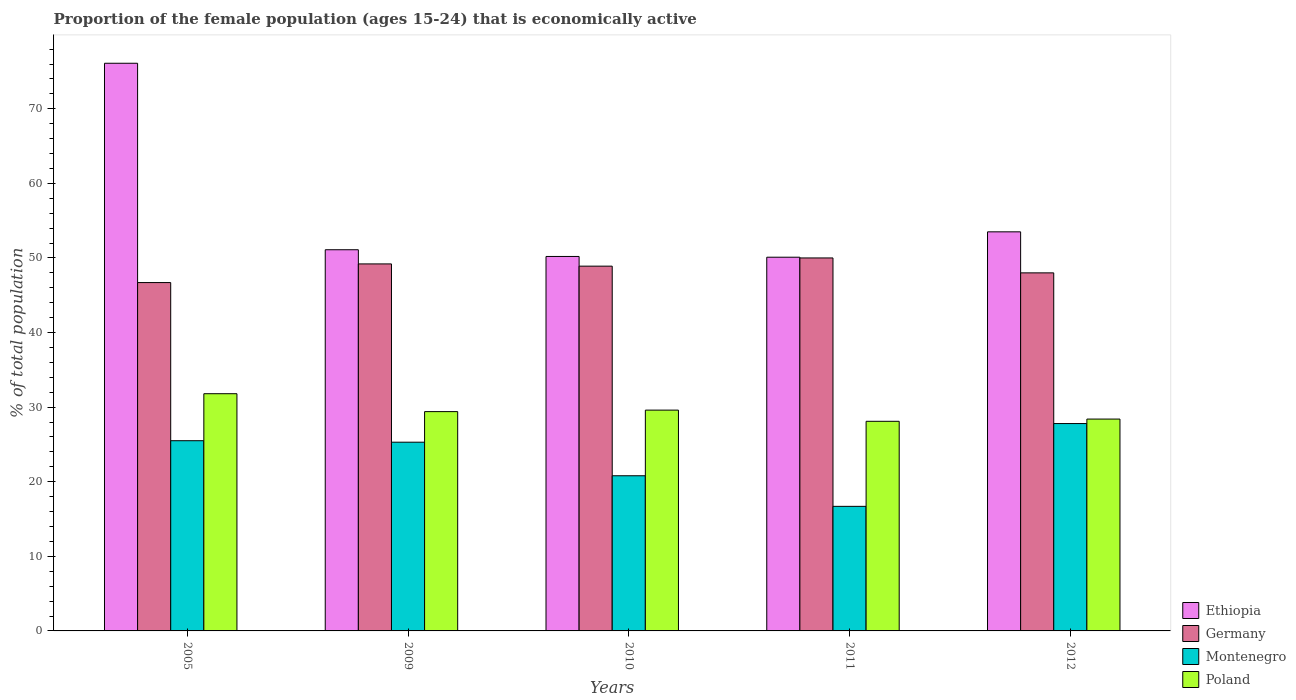How many different coloured bars are there?
Your response must be concise. 4. Are the number of bars per tick equal to the number of legend labels?
Offer a very short reply. Yes. Are the number of bars on each tick of the X-axis equal?
Give a very brief answer. Yes. How many bars are there on the 1st tick from the right?
Your answer should be compact. 4. In how many cases, is the number of bars for a given year not equal to the number of legend labels?
Your answer should be compact. 0. What is the proportion of the female population that is economically active in Germany in 2010?
Provide a succinct answer. 48.9. Across all years, what is the minimum proportion of the female population that is economically active in Montenegro?
Provide a succinct answer. 16.7. In which year was the proportion of the female population that is economically active in Germany maximum?
Offer a very short reply. 2011. What is the total proportion of the female population that is economically active in Montenegro in the graph?
Provide a short and direct response. 116.1. What is the difference between the proportion of the female population that is economically active in Germany in 2010 and that in 2011?
Offer a terse response. -1.1. What is the difference between the proportion of the female population that is economically active in Poland in 2011 and the proportion of the female population that is economically active in Ethiopia in 2009?
Ensure brevity in your answer.  -23. What is the average proportion of the female population that is economically active in Germany per year?
Offer a very short reply. 48.56. In the year 2005, what is the difference between the proportion of the female population that is economically active in Montenegro and proportion of the female population that is economically active in Poland?
Offer a very short reply. -6.3. What is the ratio of the proportion of the female population that is economically active in Poland in 2005 to that in 2011?
Give a very brief answer. 1.13. Is the proportion of the female population that is economically active in Ethiopia in 2010 less than that in 2011?
Your answer should be compact. No. What is the difference between the highest and the second highest proportion of the female population that is economically active in Ethiopia?
Keep it short and to the point. 22.6. What is the difference between the highest and the lowest proportion of the female population that is economically active in Montenegro?
Provide a succinct answer. 11.1. In how many years, is the proportion of the female population that is economically active in Ethiopia greater than the average proportion of the female population that is economically active in Ethiopia taken over all years?
Provide a short and direct response. 1. Is the sum of the proportion of the female population that is economically active in Montenegro in 2005 and 2012 greater than the maximum proportion of the female population that is economically active in Ethiopia across all years?
Your response must be concise. No. What does the 2nd bar from the left in 2012 represents?
Your answer should be compact. Germany. What does the 3rd bar from the right in 2011 represents?
Keep it short and to the point. Germany. How many years are there in the graph?
Your response must be concise. 5. Does the graph contain any zero values?
Make the answer very short. No. Does the graph contain grids?
Keep it short and to the point. No. Where does the legend appear in the graph?
Ensure brevity in your answer.  Bottom right. What is the title of the graph?
Make the answer very short. Proportion of the female population (ages 15-24) that is economically active. Does "St. Martin (French part)" appear as one of the legend labels in the graph?
Offer a terse response. No. What is the label or title of the Y-axis?
Give a very brief answer. % of total population. What is the % of total population in Ethiopia in 2005?
Offer a very short reply. 76.1. What is the % of total population of Germany in 2005?
Give a very brief answer. 46.7. What is the % of total population in Montenegro in 2005?
Offer a very short reply. 25.5. What is the % of total population of Poland in 2005?
Provide a succinct answer. 31.8. What is the % of total population in Ethiopia in 2009?
Your answer should be very brief. 51.1. What is the % of total population in Germany in 2009?
Offer a terse response. 49.2. What is the % of total population of Montenegro in 2009?
Give a very brief answer. 25.3. What is the % of total population of Poland in 2009?
Keep it short and to the point. 29.4. What is the % of total population in Ethiopia in 2010?
Offer a terse response. 50.2. What is the % of total population in Germany in 2010?
Keep it short and to the point. 48.9. What is the % of total population in Montenegro in 2010?
Give a very brief answer. 20.8. What is the % of total population in Poland in 2010?
Your answer should be compact. 29.6. What is the % of total population in Ethiopia in 2011?
Give a very brief answer. 50.1. What is the % of total population of Germany in 2011?
Ensure brevity in your answer.  50. What is the % of total population in Montenegro in 2011?
Provide a succinct answer. 16.7. What is the % of total population in Poland in 2011?
Give a very brief answer. 28.1. What is the % of total population in Ethiopia in 2012?
Make the answer very short. 53.5. What is the % of total population in Germany in 2012?
Make the answer very short. 48. What is the % of total population in Montenegro in 2012?
Offer a very short reply. 27.8. What is the % of total population of Poland in 2012?
Keep it short and to the point. 28.4. Across all years, what is the maximum % of total population of Ethiopia?
Provide a short and direct response. 76.1. Across all years, what is the maximum % of total population in Montenegro?
Offer a very short reply. 27.8. Across all years, what is the maximum % of total population of Poland?
Ensure brevity in your answer.  31.8. Across all years, what is the minimum % of total population in Ethiopia?
Ensure brevity in your answer.  50.1. Across all years, what is the minimum % of total population in Germany?
Ensure brevity in your answer.  46.7. Across all years, what is the minimum % of total population of Montenegro?
Provide a succinct answer. 16.7. Across all years, what is the minimum % of total population of Poland?
Ensure brevity in your answer.  28.1. What is the total % of total population of Ethiopia in the graph?
Your answer should be very brief. 281. What is the total % of total population in Germany in the graph?
Your answer should be compact. 242.8. What is the total % of total population in Montenegro in the graph?
Provide a succinct answer. 116.1. What is the total % of total population in Poland in the graph?
Your answer should be compact. 147.3. What is the difference between the % of total population of Montenegro in 2005 and that in 2009?
Your response must be concise. 0.2. What is the difference between the % of total population of Poland in 2005 and that in 2009?
Offer a very short reply. 2.4. What is the difference between the % of total population of Ethiopia in 2005 and that in 2010?
Provide a succinct answer. 25.9. What is the difference between the % of total population in Germany in 2005 and that in 2010?
Make the answer very short. -2.2. What is the difference between the % of total population of Montenegro in 2005 and that in 2010?
Give a very brief answer. 4.7. What is the difference between the % of total population of Poland in 2005 and that in 2010?
Provide a succinct answer. 2.2. What is the difference between the % of total population in Germany in 2005 and that in 2011?
Provide a succinct answer. -3.3. What is the difference between the % of total population in Montenegro in 2005 and that in 2011?
Your response must be concise. 8.8. What is the difference between the % of total population of Poland in 2005 and that in 2011?
Keep it short and to the point. 3.7. What is the difference between the % of total population in Ethiopia in 2005 and that in 2012?
Your answer should be compact. 22.6. What is the difference between the % of total population of Germany in 2005 and that in 2012?
Provide a short and direct response. -1.3. What is the difference between the % of total population in Poland in 2005 and that in 2012?
Provide a succinct answer. 3.4. What is the difference between the % of total population in Ethiopia in 2009 and that in 2010?
Your answer should be very brief. 0.9. What is the difference between the % of total population in Ethiopia in 2009 and that in 2011?
Your answer should be very brief. 1. What is the difference between the % of total population of Ethiopia in 2009 and that in 2012?
Keep it short and to the point. -2.4. What is the difference between the % of total population of Ethiopia in 2010 and that in 2012?
Your answer should be compact. -3.3. What is the difference between the % of total population in Germany in 2010 and that in 2012?
Give a very brief answer. 0.9. What is the difference between the % of total population of Montenegro in 2010 and that in 2012?
Your answer should be compact. -7. What is the difference between the % of total population in Germany in 2011 and that in 2012?
Offer a terse response. 2. What is the difference between the % of total population in Ethiopia in 2005 and the % of total population in Germany in 2009?
Offer a terse response. 26.9. What is the difference between the % of total population of Ethiopia in 2005 and the % of total population of Montenegro in 2009?
Keep it short and to the point. 50.8. What is the difference between the % of total population in Ethiopia in 2005 and the % of total population in Poland in 2009?
Your answer should be very brief. 46.7. What is the difference between the % of total population of Germany in 2005 and the % of total population of Montenegro in 2009?
Offer a terse response. 21.4. What is the difference between the % of total population in Germany in 2005 and the % of total population in Poland in 2009?
Make the answer very short. 17.3. What is the difference between the % of total population in Ethiopia in 2005 and the % of total population in Germany in 2010?
Offer a very short reply. 27.2. What is the difference between the % of total population in Ethiopia in 2005 and the % of total population in Montenegro in 2010?
Your answer should be very brief. 55.3. What is the difference between the % of total population of Ethiopia in 2005 and the % of total population of Poland in 2010?
Your answer should be very brief. 46.5. What is the difference between the % of total population in Germany in 2005 and the % of total population in Montenegro in 2010?
Your response must be concise. 25.9. What is the difference between the % of total population in Germany in 2005 and the % of total population in Poland in 2010?
Provide a succinct answer. 17.1. What is the difference between the % of total population of Montenegro in 2005 and the % of total population of Poland in 2010?
Provide a short and direct response. -4.1. What is the difference between the % of total population of Ethiopia in 2005 and the % of total population of Germany in 2011?
Provide a succinct answer. 26.1. What is the difference between the % of total population of Ethiopia in 2005 and the % of total population of Montenegro in 2011?
Give a very brief answer. 59.4. What is the difference between the % of total population of Ethiopia in 2005 and the % of total population of Poland in 2011?
Provide a succinct answer. 48. What is the difference between the % of total population of Germany in 2005 and the % of total population of Montenegro in 2011?
Offer a terse response. 30. What is the difference between the % of total population in Germany in 2005 and the % of total population in Poland in 2011?
Give a very brief answer. 18.6. What is the difference between the % of total population in Montenegro in 2005 and the % of total population in Poland in 2011?
Make the answer very short. -2.6. What is the difference between the % of total population in Ethiopia in 2005 and the % of total population in Germany in 2012?
Offer a terse response. 28.1. What is the difference between the % of total population in Ethiopia in 2005 and the % of total population in Montenegro in 2012?
Give a very brief answer. 48.3. What is the difference between the % of total population of Ethiopia in 2005 and the % of total population of Poland in 2012?
Offer a terse response. 47.7. What is the difference between the % of total population of Germany in 2005 and the % of total population of Montenegro in 2012?
Offer a terse response. 18.9. What is the difference between the % of total population of Germany in 2005 and the % of total population of Poland in 2012?
Make the answer very short. 18.3. What is the difference between the % of total population of Montenegro in 2005 and the % of total population of Poland in 2012?
Provide a short and direct response. -2.9. What is the difference between the % of total population of Ethiopia in 2009 and the % of total population of Montenegro in 2010?
Offer a terse response. 30.3. What is the difference between the % of total population in Germany in 2009 and the % of total population in Montenegro in 2010?
Give a very brief answer. 28.4. What is the difference between the % of total population of Germany in 2009 and the % of total population of Poland in 2010?
Keep it short and to the point. 19.6. What is the difference between the % of total population of Ethiopia in 2009 and the % of total population of Germany in 2011?
Ensure brevity in your answer.  1.1. What is the difference between the % of total population of Ethiopia in 2009 and the % of total population of Montenegro in 2011?
Your response must be concise. 34.4. What is the difference between the % of total population in Germany in 2009 and the % of total population in Montenegro in 2011?
Provide a succinct answer. 32.5. What is the difference between the % of total population of Germany in 2009 and the % of total population of Poland in 2011?
Provide a succinct answer. 21.1. What is the difference between the % of total population of Montenegro in 2009 and the % of total population of Poland in 2011?
Keep it short and to the point. -2.8. What is the difference between the % of total population of Ethiopia in 2009 and the % of total population of Montenegro in 2012?
Make the answer very short. 23.3. What is the difference between the % of total population of Ethiopia in 2009 and the % of total population of Poland in 2012?
Your answer should be very brief. 22.7. What is the difference between the % of total population of Germany in 2009 and the % of total population of Montenegro in 2012?
Offer a very short reply. 21.4. What is the difference between the % of total population of Germany in 2009 and the % of total population of Poland in 2012?
Provide a short and direct response. 20.8. What is the difference between the % of total population in Montenegro in 2009 and the % of total population in Poland in 2012?
Provide a succinct answer. -3.1. What is the difference between the % of total population of Ethiopia in 2010 and the % of total population of Germany in 2011?
Ensure brevity in your answer.  0.2. What is the difference between the % of total population of Ethiopia in 2010 and the % of total population of Montenegro in 2011?
Ensure brevity in your answer.  33.5. What is the difference between the % of total population of Ethiopia in 2010 and the % of total population of Poland in 2011?
Offer a terse response. 22.1. What is the difference between the % of total population of Germany in 2010 and the % of total population of Montenegro in 2011?
Provide a succinct answer. 32.2. What is the difference between the % of total population in Germany in 2010 and the % of total population in Poland in 2011?
Give a very brief answer. 20.8. What is the difference between the % of total population in Montenegro in 2010 and the % of total population in Poland in 2011?
Provide a succinct answer. -7.3. What is the difference between the % of total population of Ethiopia in 2010 and the % of total population of Germany in 2012?
Ensure brevity in your answer.  2.2. What is the difference between the % of total population in Ethiopia in 2010 and the % of total population in Montenegro in 2012?
Offer a terse response. 22.4. What is the difference between the % of total population in Ethiopia in 2010 and the % of total population in Poland in 2012?
Give a very brief answer. 21.8. What is the difference between the % of total population in Germany in 2010 and the % of total population in Montenegro in 2012?
Offer a terse response. 21.1. What is the difference between the % of total population in Germany in 2010 and the % of total population in Poland in 2012?
Your answer should be compact. 20.5. What is the difference between the % of total population in Ethiopia in 2011 and the % of total population in Germany in 2012?
Your answer should be very brief. 2.1. What is the difference between the % of total population in Ethiopia in 2011 and the % of total population in Montenegro in 2012?
Give a very brief answer. 22.3. What is the difference between the % of total population in Ethiopia in 2011 and the % of total population in Poland in 2012?
Ensure brevity in your answer.  21.7. What is the difference between the % of total population in Germany in 2011 and the % of total population in Montenegro in 2012?
Provide a succinct answer. 22.2. What is the difference between the % of total population of Germany in 2011 and the % of total population of Poland in 2012?
Your response must be concise. 21.6. What is the difference between the % of total population of Montenegro in 2011 and the % of total population of Poland in 2012?
Keep it short and to the point. -11.7. What is the average % of total population of Ethiopia per year?
Give a very brief answer. 56.2. What is the average % of total population of Germany per year?
Ensure brevity in your answer.  48.56. What is the average % of total population of Montenegro per year?
Give a very brief answer. 23.22. What is the average % of total population in Poland per year?
Make the answer very short. 29.46. In the year 2005, what is the difference between the % of total population in Ethiopia and % of total population in Germany?
Your answer should be very brief. 29.4. In the year 2005, what is the difference between the % of total population in Ethiopia and % of total population in Montenegro?
Offer a terse response. 50.6. In the year 2005, what is the difference between the % of total population in Ethiopia and % of total population in Poland?
Give a very brief answer. 44.3. In the year 2005, what is the difference between the % of total population in Germany and % of total population in Montenegro?
Your answer should be very brief. 21.2. In the year 2009, what is the difference between the % of total population in Ethiopia and % of total population in Germany?
Provide a short and direct response. 1.9. In the year 2009, what is the difference between the % of total population of Ethiopia and % of total population of Montenegro?
Your answer should be compact. 25.8. In the year 2009, what is the difference between the % of total population of Ethiopia and % of total population of Poland?
Provide a succinct answer. 21.7. In the year 2009, what is the difference between the % of total population of Germany and % of total population of Montenegro?
Provide a succinct answer. 23.9. In the year 2009, what is the difference between the % of total population in Germany and % of total population in Poland?
Your answer should be compact. 19.8. In the year 2009, what is the difference between the % of total population of Montenegro and % of total population of Poland?
Give a very brief answer. -4.1. In the year 2010, what is the difference between the % of total population of Ethiopia and % of total population of Germany?
Your answer should be very brief. 1.3. In the year 2010, what is the difference between the % of total population in Ethiopia and % of total population in Montenegro?
Your answer should be compact. 29.4. In the year 2010, what is the difference between the % of total population in Ethiopia and % of total population in Poland?
Provide a short and direct response. 20.6. In the year 2010, what is the difference between the % of total population in Germany and % of total population in Montenegro?
Ensure brevity in your answer.  28.1. In the year 2010, what is the difference between the % of total population in Germany and % of total population in Poland?
Keep it short and to the point. 19.3. In the year 2011, what is the difference between the % of total population in Ethiopia and % of total population in Germany?
Ensure brevity in your answer.  0.1. In the year 2011, what is the difference between the % of total population of Ethiopia and % of total population of Montenegro?
Ensure brevity in your answer.  33.4. In the year 2011, what is the difference between the % of total population in Germany and % of total population in Montenegro?
Give a very brief answer. 33.3. In the year 2011, what is the difference between the % of total population of Germany and % of total population of Poland?
Your answer should be compact. 21.9. In the year 2011, what is the difference between the % of total population in Montenegro and % of total population in Poland?
Provide a short and direct response. -11.4. In the year 2012, what is the difference between the % of total population in Ethiopia and % of total population in Germany?
Your answer should be compact. 5.5. In the year 2012, what is the difference between the % of total population of Ethiopia and % of total population of Montenegro?
Keep it short and to the point. 25.7. In the year 2012, what is the difference between the % of total population of Ethiopia and % of total population of Poland?
Make the answer very short. 25.1. In the year 2012, what is the difference between the % of total population in Germany and % of total population in Montenegro?
Keep it short and to the point. 20.2. In the year 2012, what is the difference between the % of total population in Germany and % of total population in Poland?
Make the answer very short. 19.6. What is the ratio of the % of total population of Ethiopia in 2005 to that in 2009?
Give a very brief answer. 1.49. What is the ratio of the % of total population of Germany in 2005 to that in 2009?
Provide a succinct answer. 0.95. What is the ratio of the % of total population in Montenegro in 2005 to that in 2009?
Make the answer very short. 1.01. What is the ratio of the % of total population of Poland in 2005 to that in 2009?
Your response must be concise. 1.08. What is the ratio of the % of total population in Ethiopia in 2005 to that in 2010?
Your answer should be compact. 1.52. What is the ratio of the % of total population in Germany in 2005 to that in 2010?
Ensure brevity in your answer.  0.95. What is the ratio of the % of total population in Montenegro in 2005 to that in 2010?
Make the answer very short. 1.23. What is the ratio of the % of total population in Poland in 2005 to that in 2010?
Your answer should be very brief. 1.07. What is the ratio of the % of total population of Ethiopia in 2005 to that in 2011?
Provide a succinct answer. 1.52. What is the ratio of the % of total population in Germany in 2005 to that in 2011?
Offer a terse response. 0.93. What is the ratio of the % of total population of Montenegro in 2005 to that in 2011?
Ensure brevity in your answer.  1.53. What is the ratio of the % of total population of Poland in 2005 to that in 2011?
Offer a terse response. 1.13. What is the ratio of the % of total population of Ethiopia in 2005 to that in 2012?
Provide a short and direct response. 1.42. What is the ratio of the % of total population of Germany in 2005 to that in 2012?
Your answer should be very brief. 0.97. What is the ratio of the % of total population in Montenegro in 2005 to that in 2012?
Your response must be concise. 0.92. What is the ratio of the % of total population in Poland in 2005 to that in 2012?
Your answer should be very brief. 1.12. What is the ratio of the % of total population in Ethiopia in 2009 to that in 2010?
Provide a short and direct response. 1.02. What is the ratio of the % of total population in Germany in 2009 to that in 2010?
Provide a short and direct response. 1.01. What is the ratio of the % of total population of Montenegro in 2009 to that in 2010?
Provide a succinct answer. 1.22. What is the ratio of the % of total population of Ethiopia in 2009 to that in 2011?
Your response must be concise. 1.02. What is the ratio of the % of total population in Montenegro in 2009 to that in 2011?
Make the answer very short. 1.51. What is the ratio of the % of total population in Poland in 2009 to that in 2011?
Provide a succinct answer. 1.05. What is the ratio of the % of total population in Ethiopia in 2009 to that in 2012?
Ensure brevity in your answer.  0.96. What is the ratio of the % of total population in Germany in 2009 to that in 2012?
Your answer should be very brief. 1.02. What is the ratio of the % of total population in Montenegro in 2009 to that in 2012?
Your answer should be compact. 0.91. What is the ratio of the % of total population of Poland in 2009 to that in 2012?
Provide a short and direct response. 1.04. What is the ratio of the % of total population of Ethiopia in 2010 to that in 2011?
Provide a short and direct response. 1. What is the ratio of the % of total population in Germany in 2010 to that in 2011?
Offer a very short reply. 0.98. What is the ratio of the % of total population of Montenegro in 2010 to that in 2011?
Your response must be concise. 1.25. What is the ratio of the % of total population in Poland in 2010 to that in 2011?
Your response must be concise. 1.05. What is the ratio of the % of total population in Ethiopia in 2010 to that in 2012?
Your answer should be very brief. 0.94. What is the ratio of the % of total population in Germany in 2010 to that in 2012?
Ensure brevity in your answer.  1.02. What is the ratio of the % of total population of Montenegro in 2010 to that in 2012?
Make the answer very short. 0.75. What is the ratio of the % of total population in Poland in 2010 to that in 2012?
Give a very brief answer. 1.04. What is the ratio of the % of total population in Ethiopia in 2011 to that in 2012?
Keep it short and to the point. 0.94. What is the ratio of the % of total population of Germany in 2011 to that in 2012?
Provide a short and direct response. 1.04. What is the ratio of the % of total population of Montenegro in 2011 to that in 2012?
Your answer should be very brief. 0.6. What is the ratio of the % of total population of Poland in 2011 to that in 2012?
Provide a short and direct response. 0.99. What is the difference between the highest and the second highest % of total population in Ethiopia?
Make the answer very short. 22.6. What is the difference between the highest and the second highest % of total population in Germany?
Make the answer very short. 0.8. What is the difference between the highest and the second highest % of total population in Poland?
Make the answer very short. 2.2. What is the difference between the highest and the lowest % of total population of Ethiopia?
Provide a short and direct response. 26. What is the difference between the highest and the lowest % of total population in Germany?
Your answer should be very brief. 3.3. What is the difference between the highest and the lowest % of total population in Poland?
Your answer should be very brief. 3.7. 